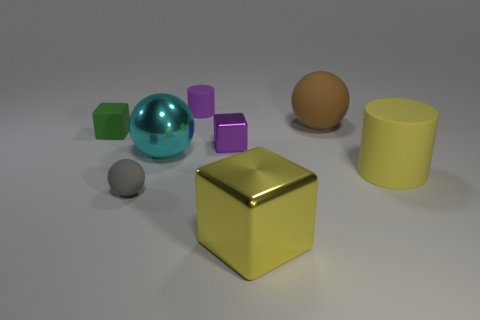Is the number of rubber objects that are behind the large yellow cylinder the same as the number of small purple blocks?
Ensure brevity in your answer.  No. There is a small block that is right of the tiny gray matte object; does it have the same color as the small cylinder?
Ensure brevity in your answer.  Yes. What material is the thing that is both on the right side of the big yellow shiny block and behind the yellow rubber object?
Keep it short and to the point. Rubber. There is a rubber sphere in front of the cyan metallic thing; is there a ball on the right side of it?
Give a very brief answer. Yes. Do the big cylinder and the gray object have the same material?
Offer a very short reply. Yes. There is a tiny object that is behind the small rubber sphere and in front of the green matte cube; what is its shape?
Your answer should be compact. Cube. There is a purple rubber cylinder behind the large thing that is behind the small purple metal block; what is its size?
Your response must be concise. Small. How many blue rubber objects have the same shape as the small purple metallic thing?
Offer a terse response. 0. Does the big cylinder have the same color as the large block?
Offer a terse response. Yes. Is there anything else that is the same shape as the small metallic object?
Keep it short and to the point. Yes. 